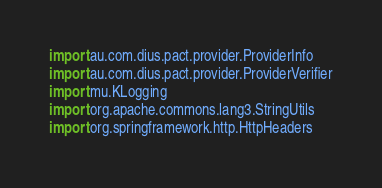<code> <loc_0><loc_0><loc_500><loc_500><_Kotlin_>import au.com.dius.pact.provider.ProviderInfo
import au.com.dius.pact.provider.ProviderVerifier
import mu.KLogging
import org.apache.commons.lang3.StringUtils
import org.springframework.http.HttpHeaders</code> 